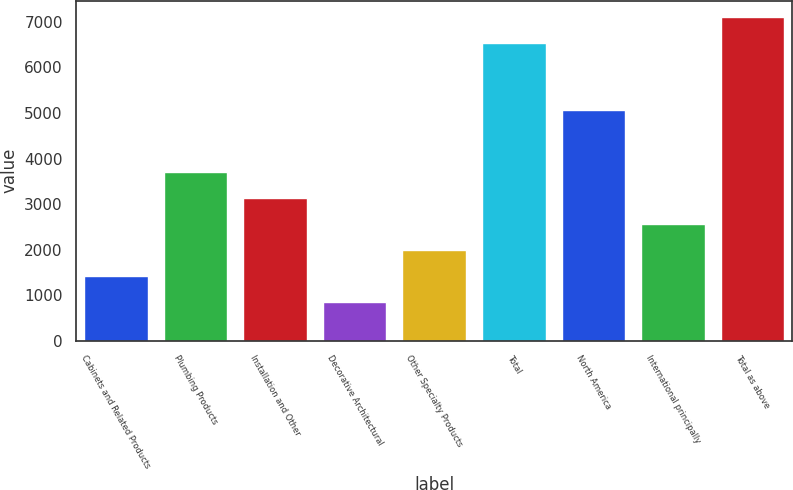<chart> <loc_0><loc_0><loc_500><loc_500><bar_chart><fcel>Cabinets and Related Products<fcel>Plumbing Products<fcel>Installation and Other<fcel>Decorative Architectural<fcel>Other Specialty Products<fcel>Total<fcel>North America<fcel>International principally<fcel>Total as above<nl><fcel>1420.3<fcel>3697.5<fcel>3128.2<fcel>851<fcel>1989.6<fcel>6544<fcel>5063<fcel>2558.9<fcel>7113.3<nl></chart> 